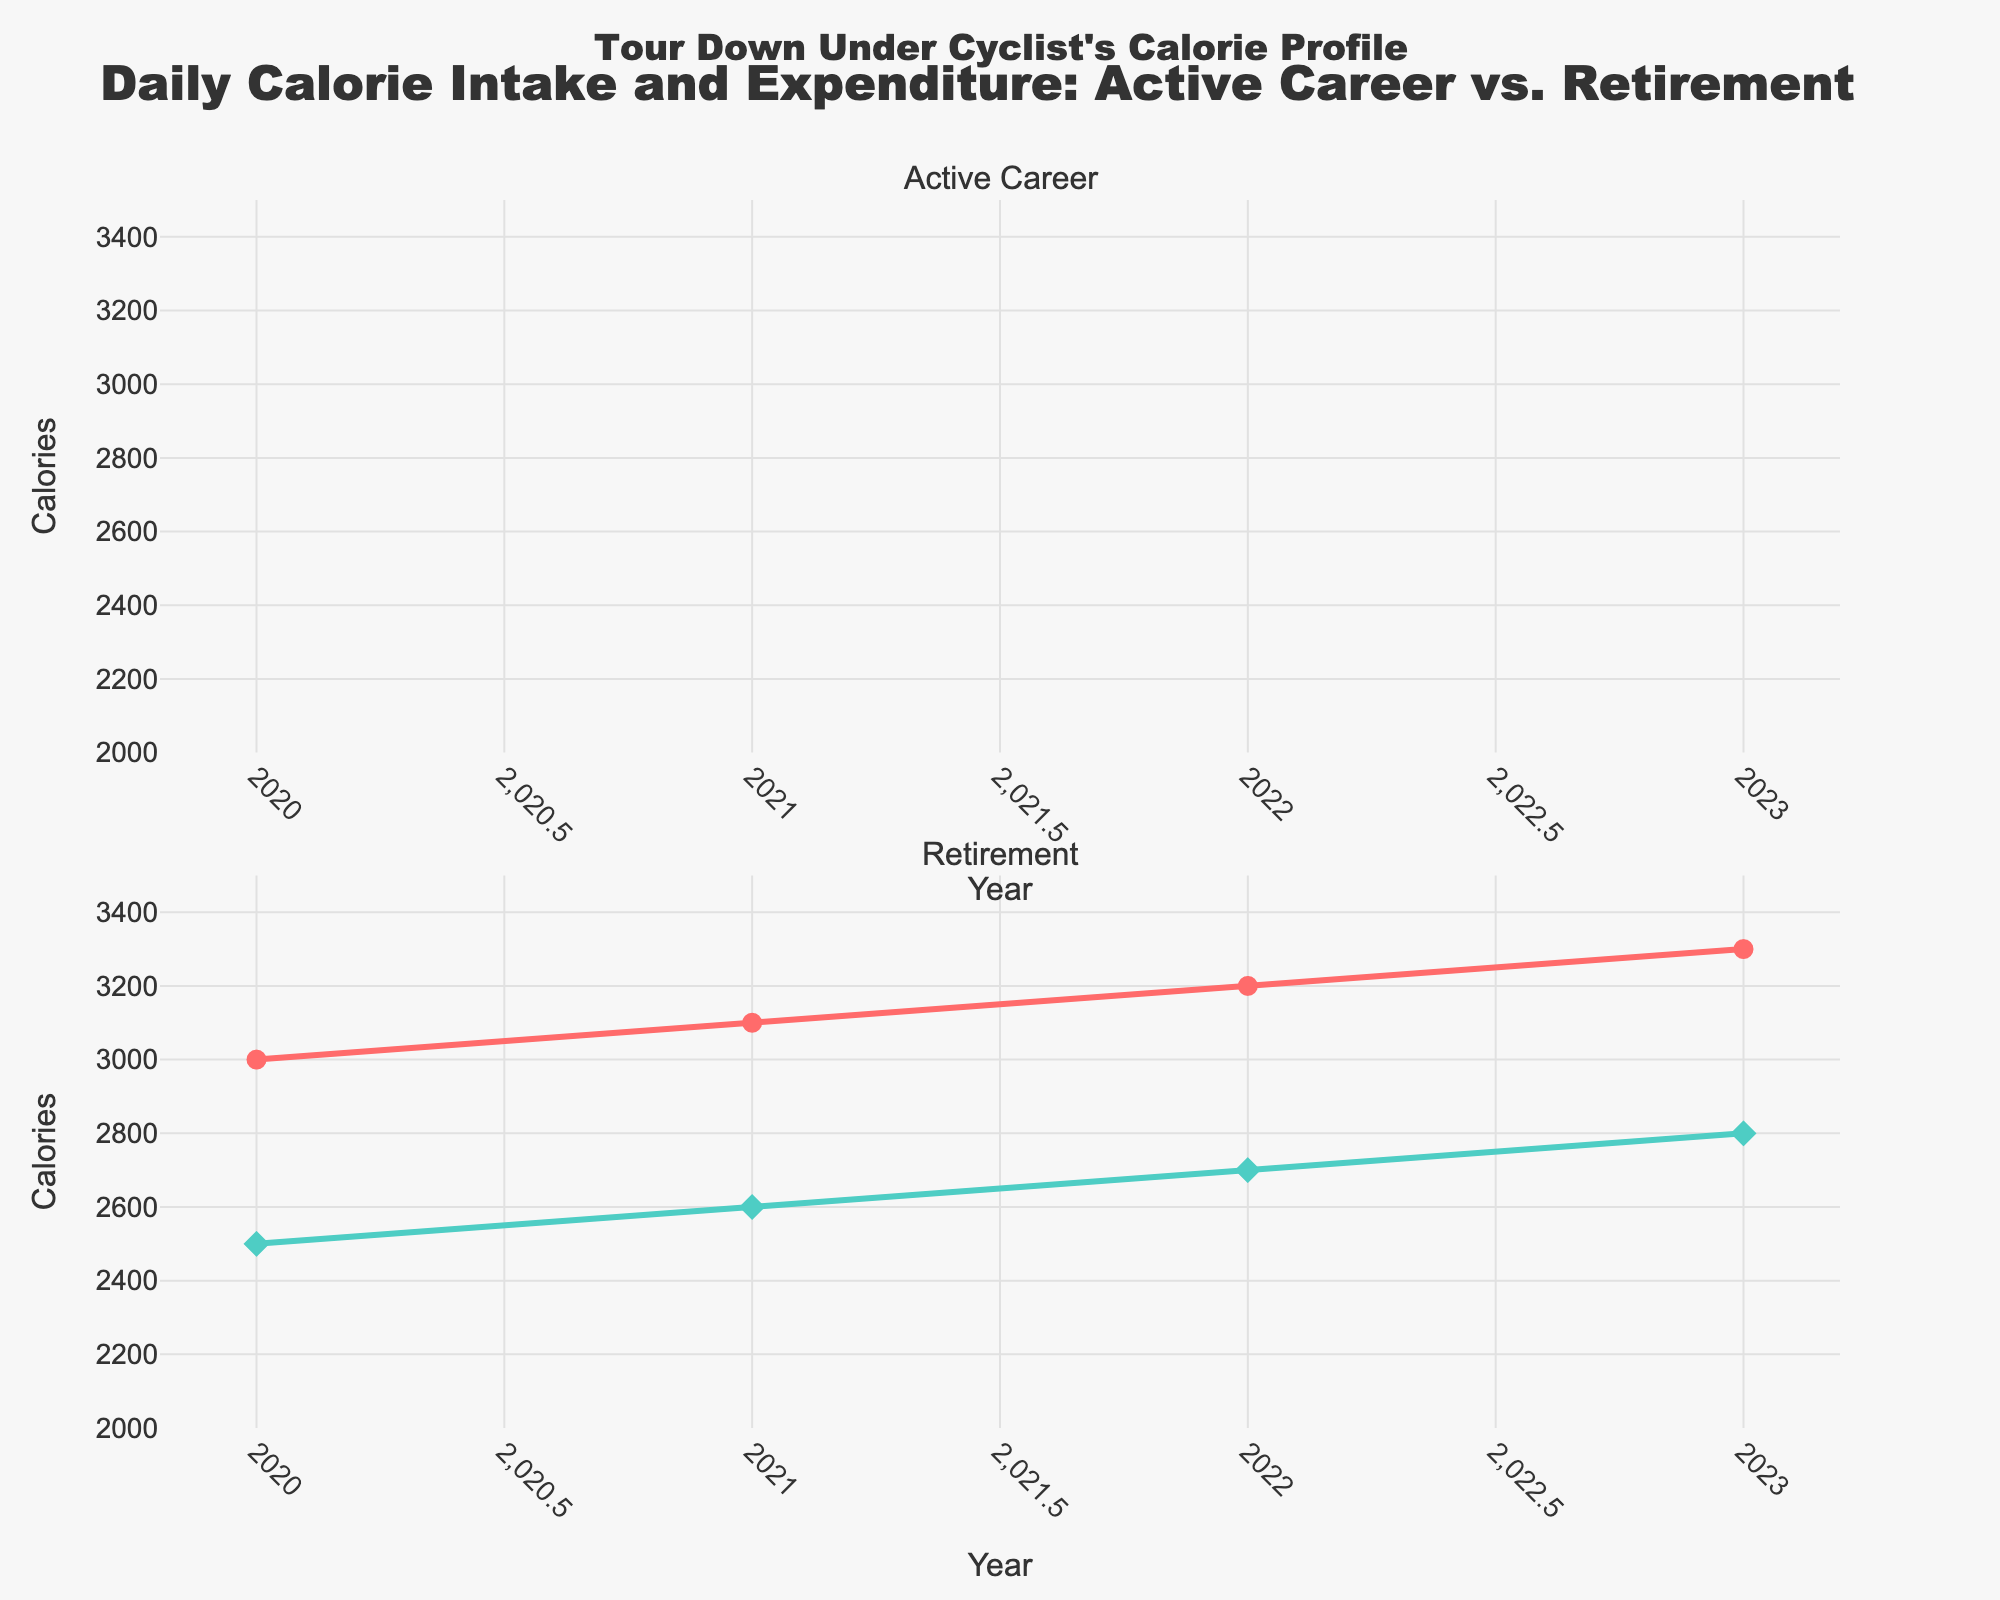what is the title of the figure? The title is located at the top of the figure. The text reads "Daily Calorie Intake and Expenditure: Active Career vs. Retirement", which summarizes the content.
Answer: Daily Calorie Intake and Expenditure: Active Career vs. Retirement what are the colors used for calorie intake and expenditure lines? In both subplots, calorie intake is depicted using a red line, and expenditure is shown with a teal line. This is visible from the color of the lines and corresponding markers.
Answer: Red for intake, teal for expenditure which year's retired calorie intake is the highest? Examine the second subplot for retirement, and identify the year with the highest point on the red line. In this case, it is the year 2023.
Answer: 2023 how many years of data are displayed in the figure for the retired intake and expenditure? Count the number of data points along the x-axis for retired intake and expenditure in the second subplot. There are data points for 4 years: 2020, 2021, 2022, and 2023.
Answer: 4 years what is the difference between retired intake and expenditure in 2020? Look at the values for "Retired_Intake" and "Retired_Expenditure" for the year 2020. The difference is calculated as 3000 (intake) - 2500 (expenditure).
Answer: 500 how does the trend of retired intake compare to retired expenditure from 2020 to 2023? Compare the slopes of the two lines in the second subplot. Both lines show an upward trend, with the intake consistently higher than expenditure for each year, but both increase gradually over the years.
Answer: Both increase, intake higher between active and retired periods, which has higher calorie expenditure? Compare the expenditure trends in both subplots. The active period subplot shows higher overall calorie expenditure since no data points are present for active period, rely on the knowledge on the right axis range which highlights highest calorie range.
Answer: active period which period shows a consistent increase in calorie intake over time, active career or retirement? Observe the trends in the lines. In the subplot for retirement, the red line shows a steady rise over time. In the subplot for the active career, there is no data available.
Answer: retirement 